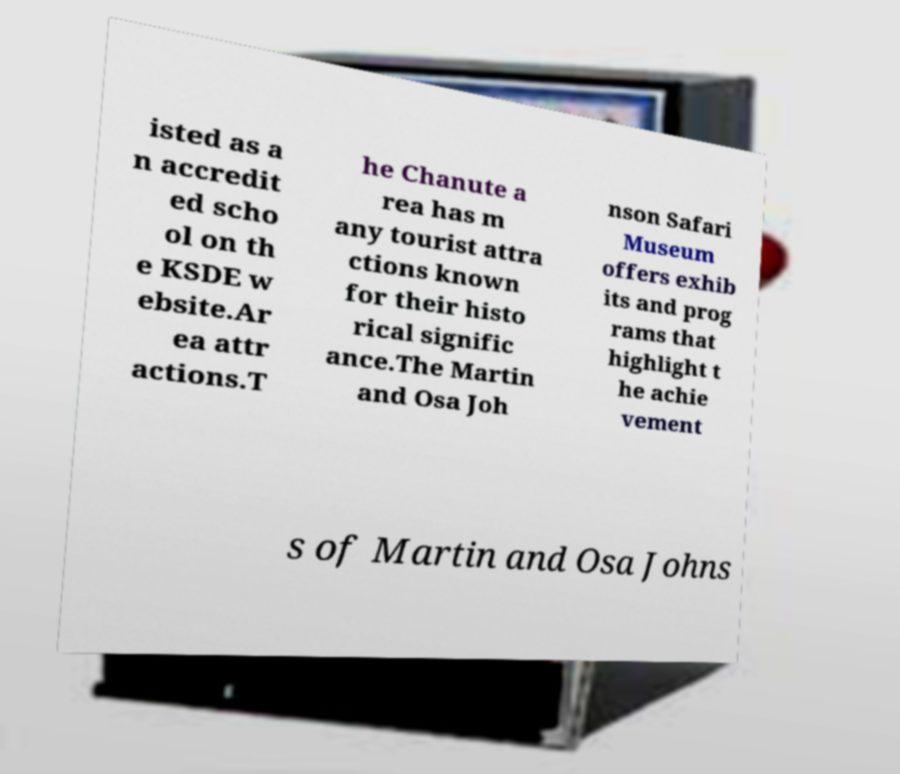Please identify and transcribe the text found in this image. isted as a n accredit ed scho ol on th e KSDE w ebsite.Ar ea attr actions.T he Chanute a rea has m any tourist attra ctions known for their histo rical signific ance.The Martin and Osa Joh nson Safari Museum offers exhib its and prog rams that highlight t he achie vement s of Martin and Osa Johns 